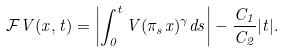<formula> <loc_0><loc_0><loc_500><loc_500>\mathcal { F } V ( x , t ) = \left | \int _ { 0 } ^ { t } V ( \pi _ { s } x ) ^ { \gamma } d s \right | - \frac { C _ { 1 } } { C _ { 2 } } | t | .</formula> 